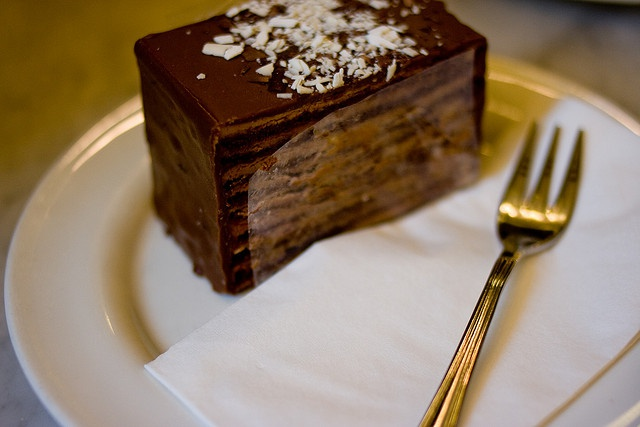Describe the objects in this image and their specific colors. I can see cake in maroon, black, and darkgray tones and fork in maroon, olive, and black tones in this image. 